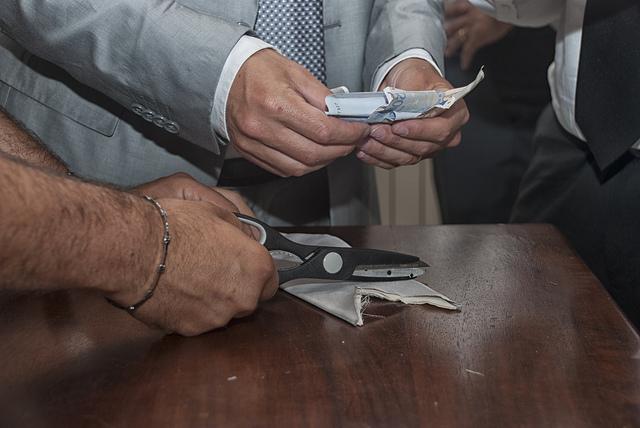Do you see a bracelet?
Answer briefly. Yes. What sharp object is the man holding?
Quick response, please. Scissors. What are they making?
Give a very brief answer. Money. How many ties are shown?
Concise answer only. 2. 